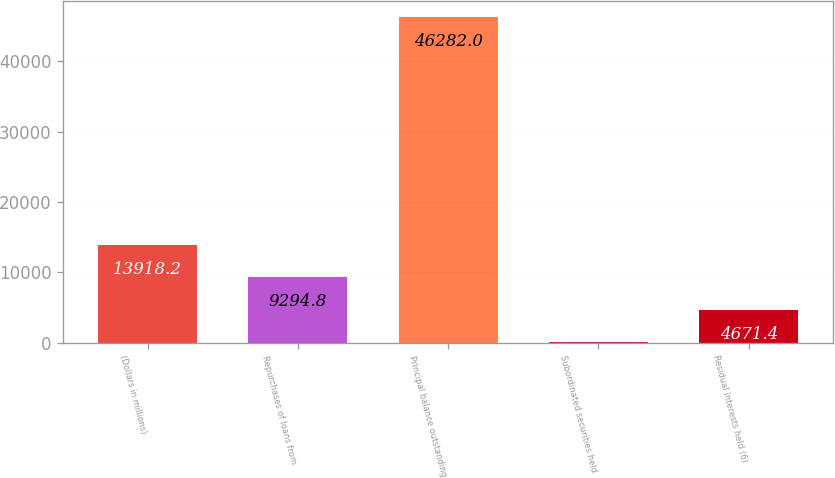Convert chart to OTSL. <chart><loc_0><loc_0><loc_500><loc_500><bar_chart><fcel>(Dollars in millions)<fcel>Repurchases of loans from<fcel>Principal balance outstanding<fcel>Subordinated securities held<fcel>Residual interests held (6)<nl><fcel>13918.2<fcel>9294.8<fcel>46282<fcel>48<fcel>4671.4<nl></chart> 